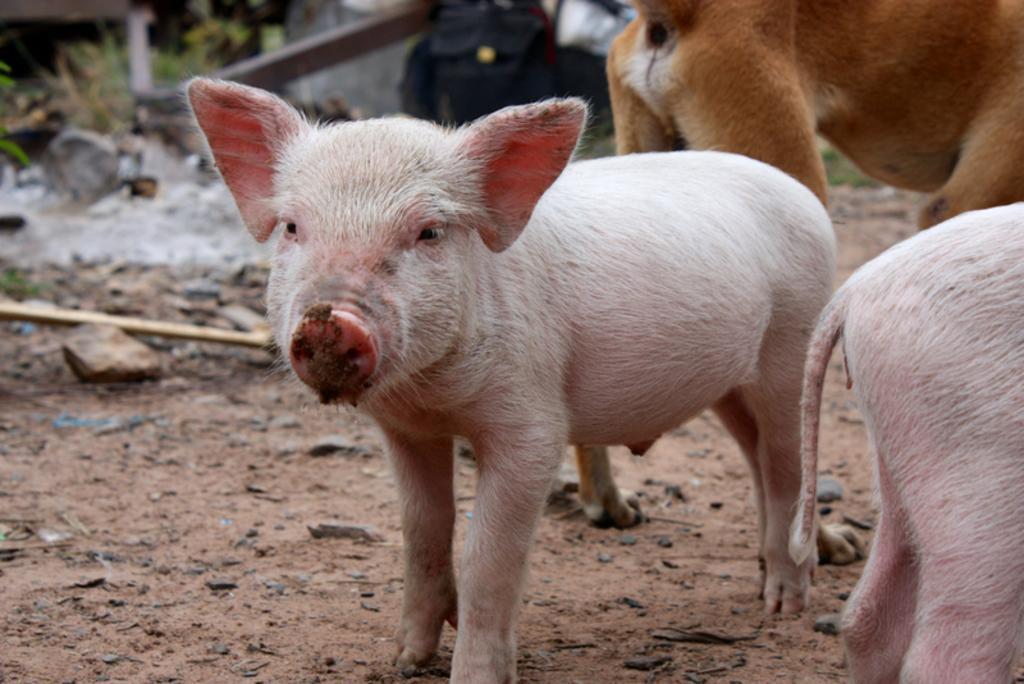Please provide a concise description of this image. In this image there are animals. At the bottom there are rocks and we can see grass. 